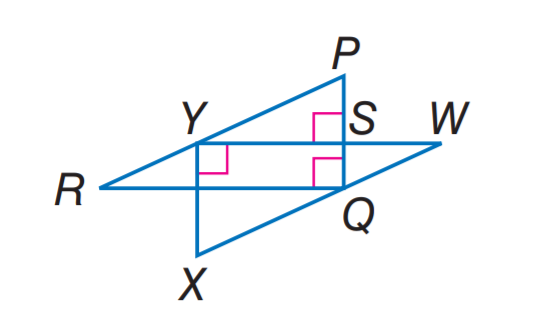Question: If P R \parallel W X, W X = 10, X Y = 6, W Y = 8, R Y = 5, and P S = 3, find P Q.
Choices:
A. 3
B. 4
C. 5
D. 6
Answer with the letter. Answer: D Question: If P R \parallel W X, W X = 10, X Y = 6, W Y = 8, R Y = 5, and P S = 3, find S Y.
Choices:
A. 3
B. 4
C. 5
D. 6
Answer with the letter. Answer: B 